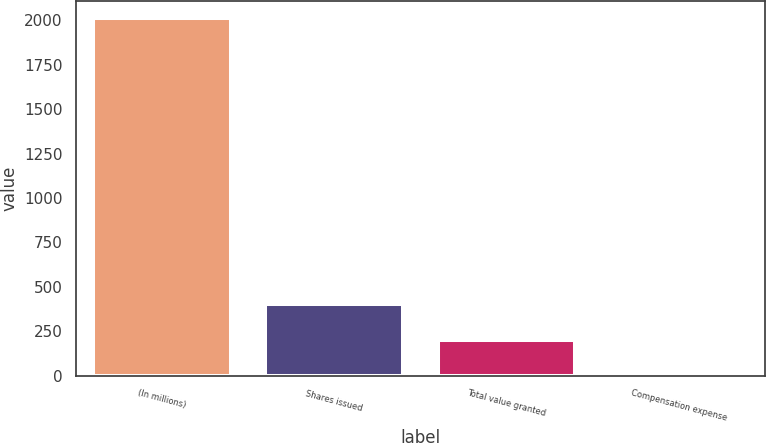<chart> <loc_0><loc_0><loc_500><loc_500><bar_chart><fcel>(In millions)<fcel>Shares issued<fcel>Total value granted<fcel>Compensation expense<nl><fcel>2011<fcel>402.52<fcel>201.46<fcel>0.4<nl></chart> 